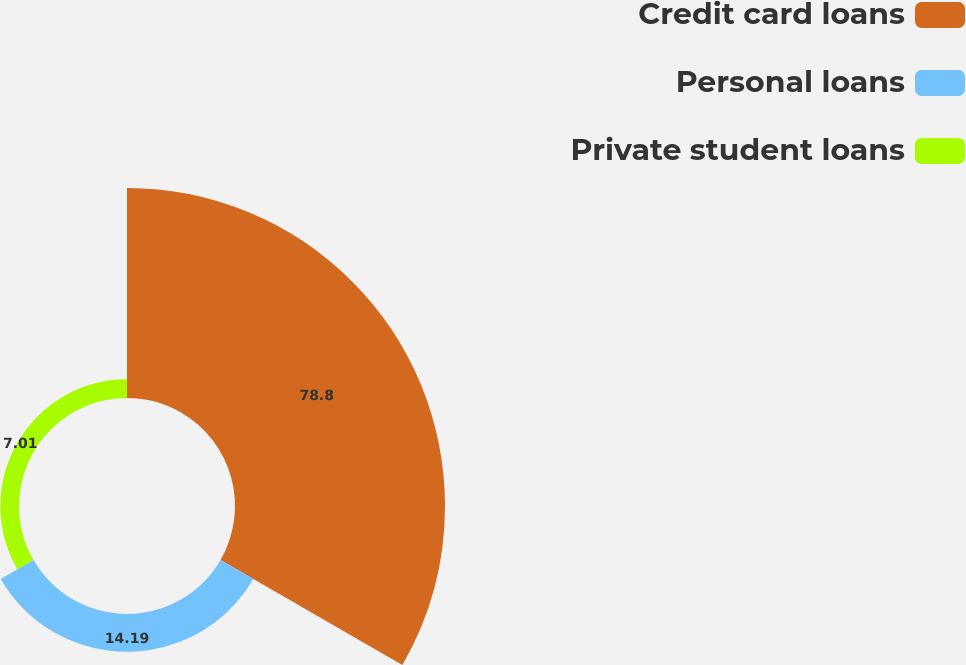Convert chart to OTSL. <chart><loc_0><loc_0><loc_500><loc_500><pie_chart><fcel>Credit card loans<fcel>Personal loans<fcel>Private student loans<nl><fcel>78.81%<fcel>14.19%<fcel>7.01%<nl></chart> 